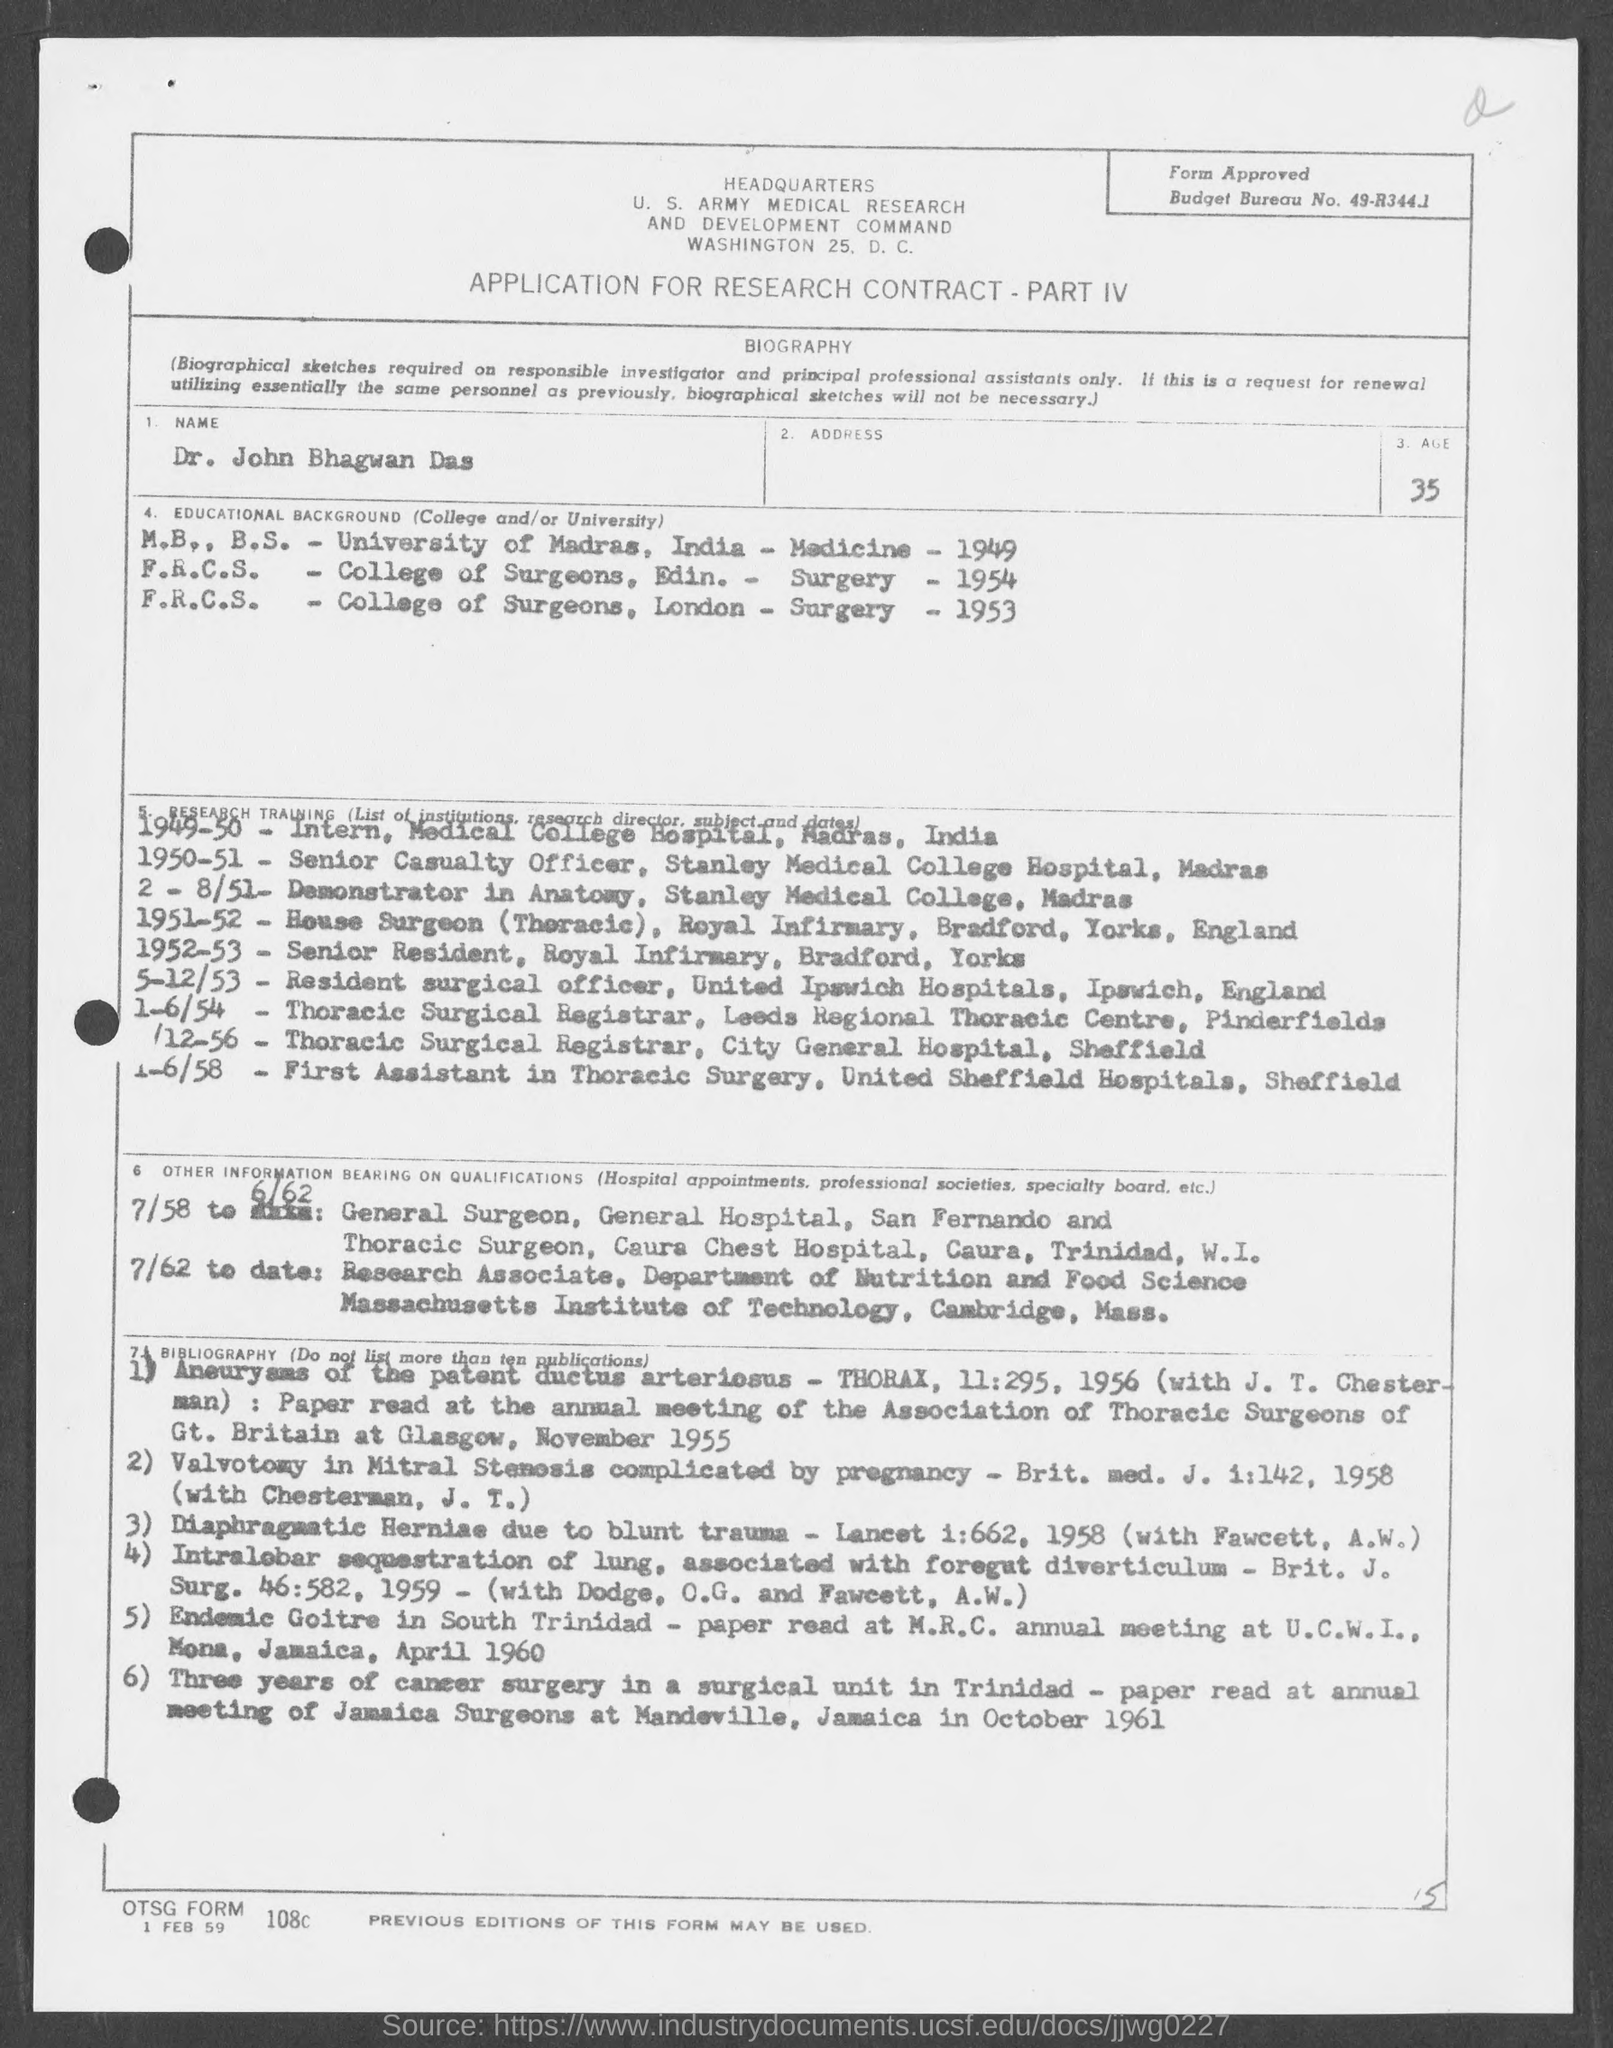Specify some key components in this picture. What is the age?" the speaker declared, "It is 35.. The date on the document is February 1st, 1959. Dr. John Bhagwan Das is a person known as "What is the Name? 